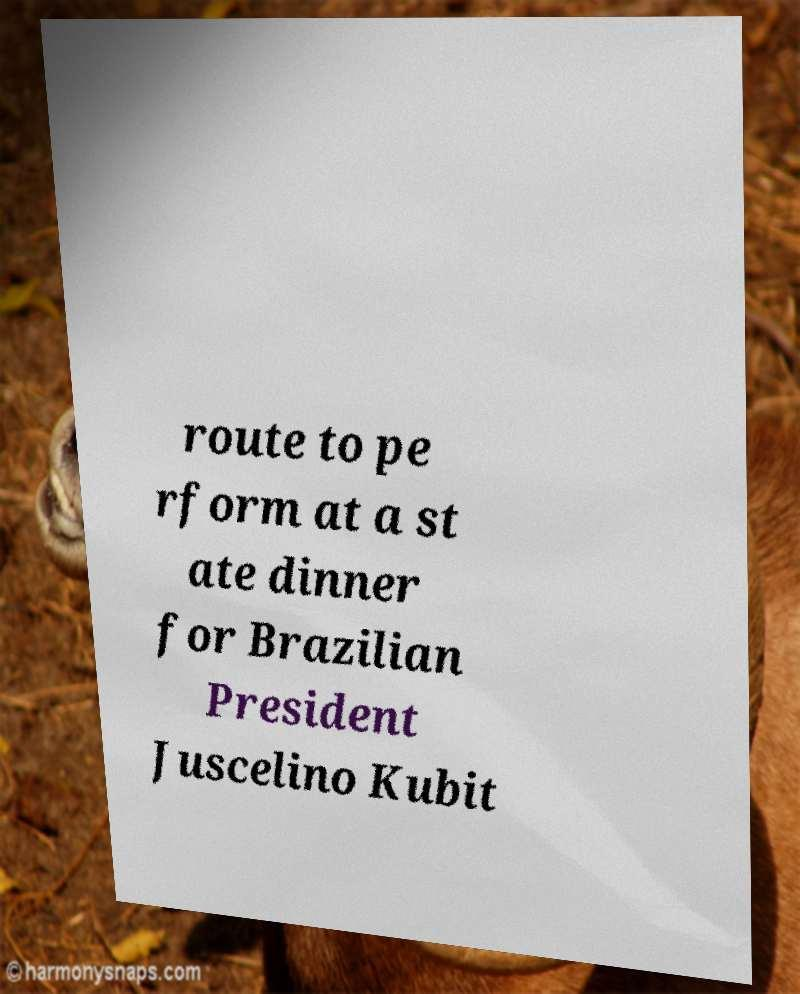Can you accurately transcribe the text from the provided image for me? route to pe rform at a st ate dinner for Brazilian President Juscelino Kubit 